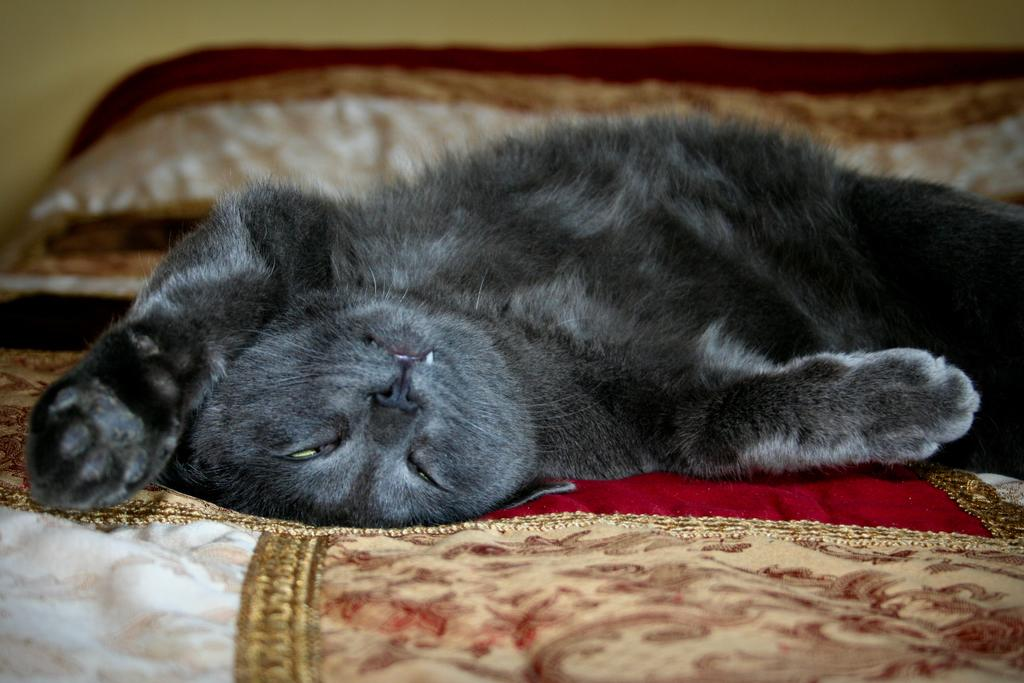What type of animal is present in the image? There is a cat in the image. Where is the cat located? The cat is lying on a bed. What can be seen in the background of the image? There is a wall in the background of the image. What type of plantation can be seen in the image? There is no plantation present in the image; it features a cat lying on a bed with a wall in the background. 